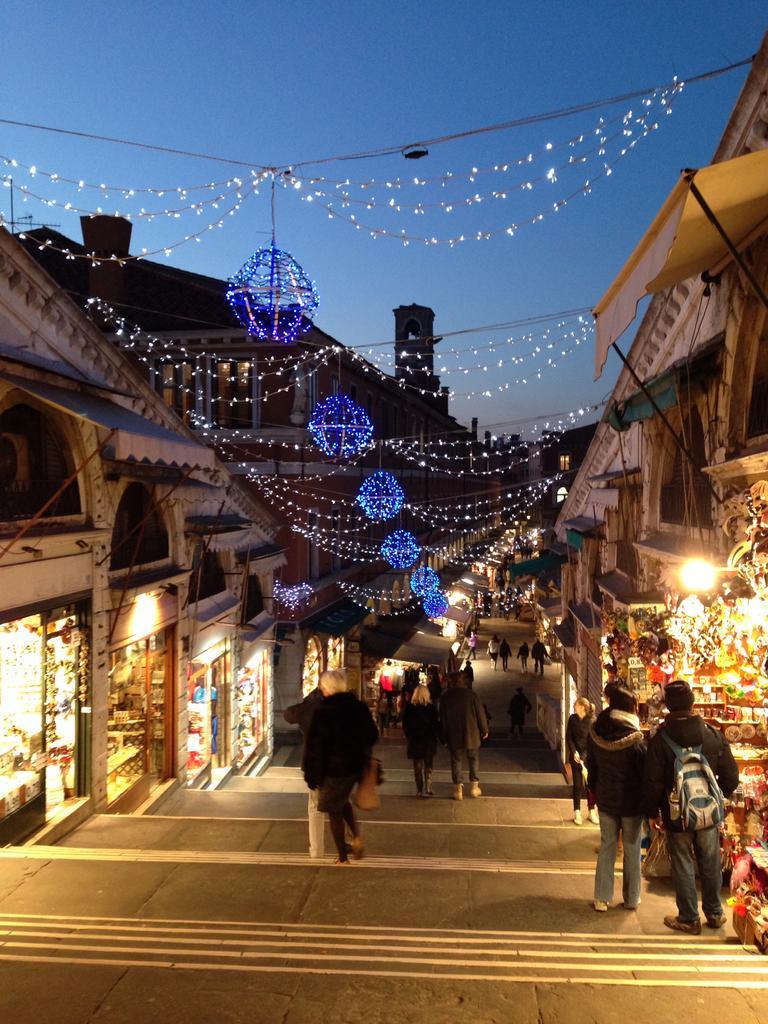Please provide a concise description of this image. In this picture we can see a few people on the stairs and some people at the back. There are some decorative lights and wires are visible on top. We can see the buildings in the background. Sky is blue in color. 